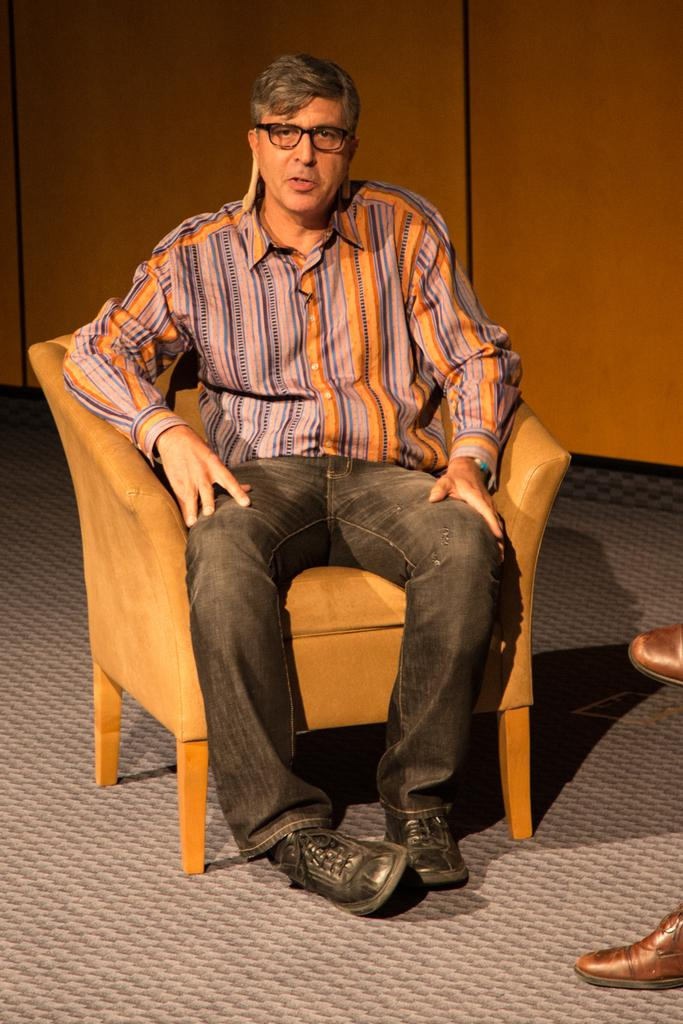Who is present in the image? There is a man in the image. What is the man doing in the image? The man is sitting on a chair. Is the man looking at anything or anyone in the image? Yes, the man is looking at someone. What type of bridge can be seen in the image? There is no bridge present in the image; it features a man sitting on a chair and looking at someone. Is there an owl perched on the man's shoulder in the image? No, there is no owl present in the image. 